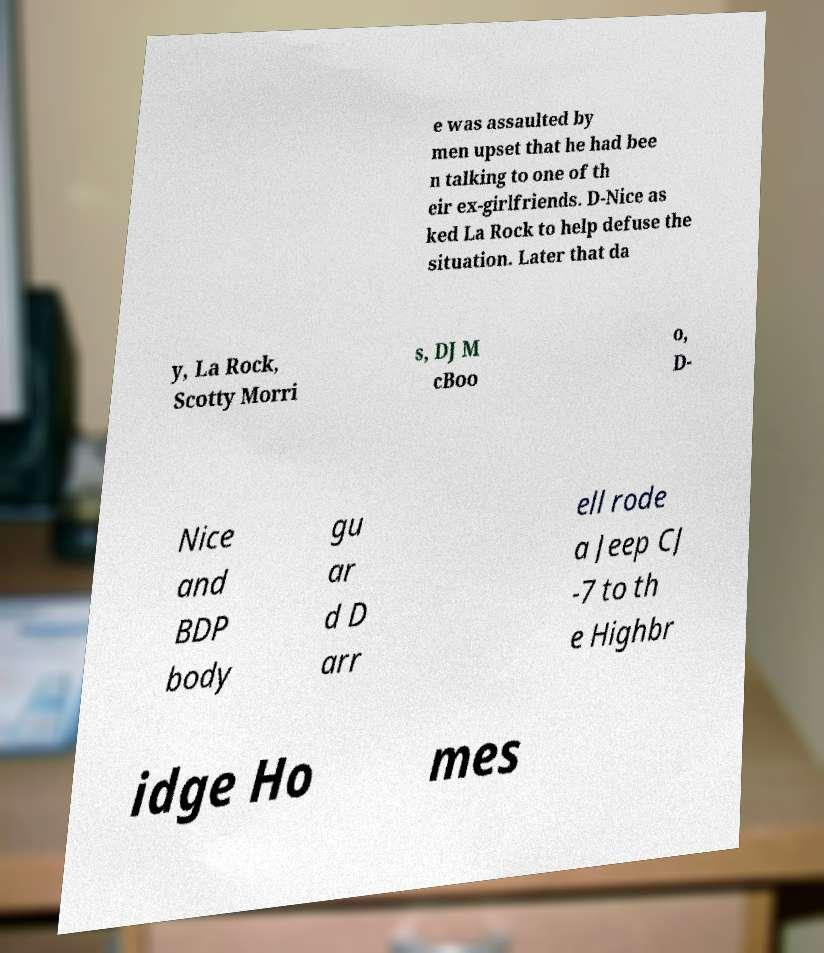Could you extract and type out the text from this image? e was assaulted by men upset that he had bee n talking to one of th eir ex-girlfriends. D-Nice as ked La Rock to help defuse the situation. Later that da y, La Rock, Scotty Morri s, DJ M cBoo o, D- Nice and BDP body gu ar d D arr ell rode a Jeep CJ -7 to th e Highbr idge Ho mes 